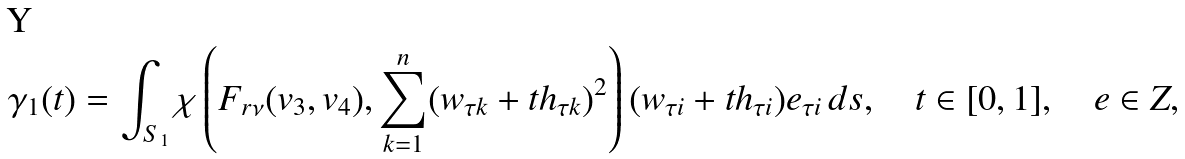Convert formula to latex. <formula><loc_0><loc_0><loc_500><loc_500>\gamma _ { 1 } ( t ) = \int _ { S _ { 1 } } \chi \left ( F _ { r \nu } ( v _ { 3 } , v _ { 4 } ) , \sum _ { k = 1 } ^ { n } ( w _ { \tau k } + t h _ { \tau k } ) ^ { 2 } \right ) ( w _ { \tau i } + t h _ { \tau i } ) e _ { \tau i } \, d s , \quad t \in [ 0 , 1 ] , \quad e \in Z ,</formula> 